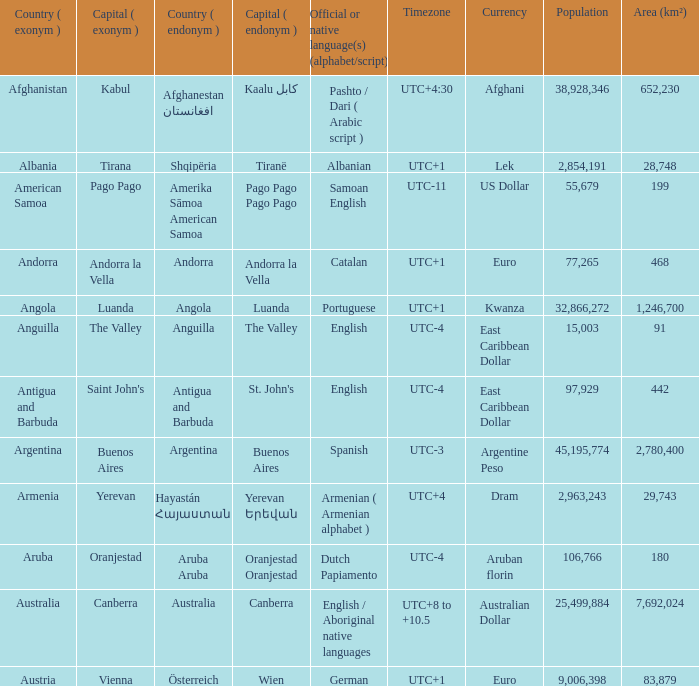What is the local name given to the city of Canberra? Canberra. 